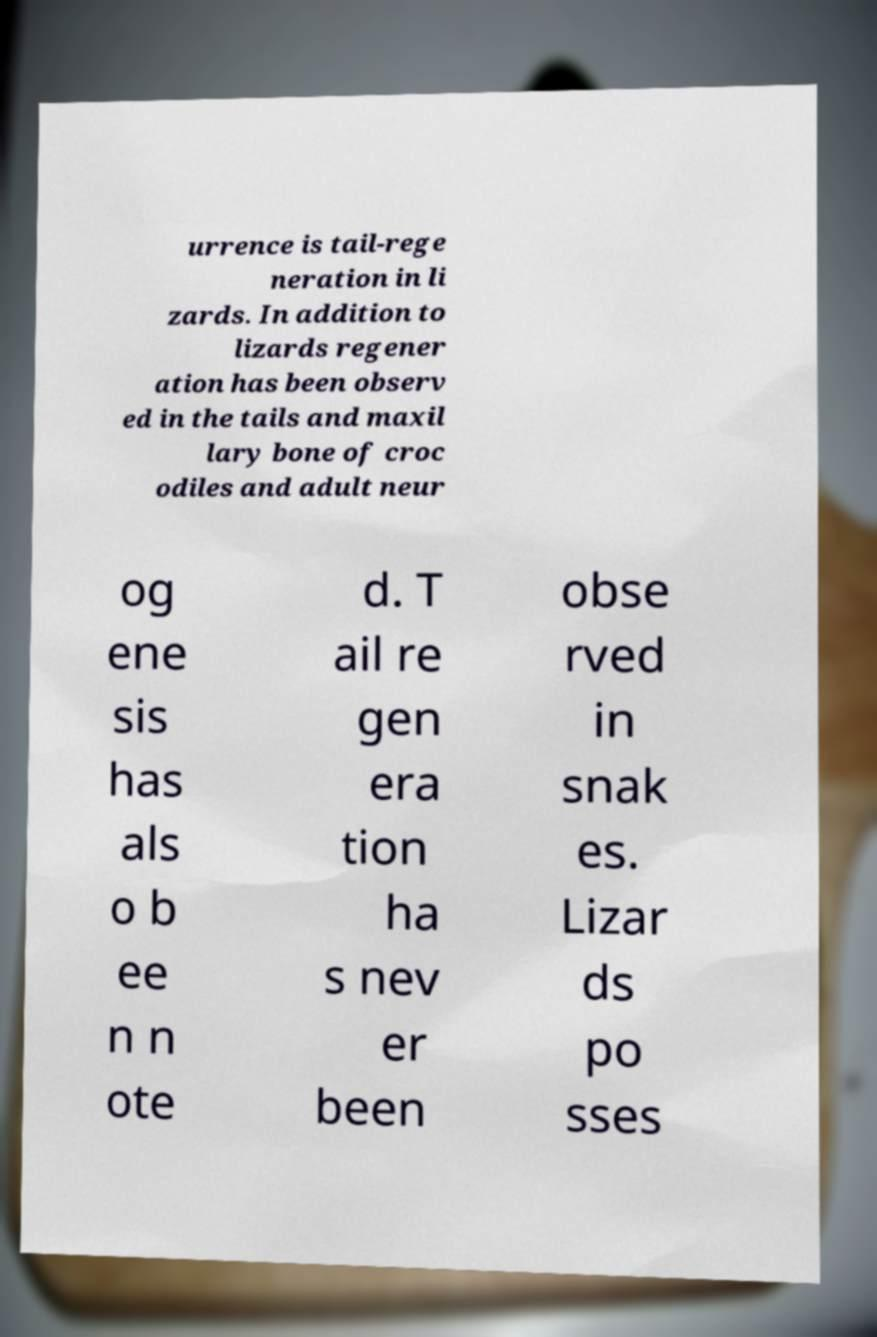Could you assist in decoding the text presented in this image and type it out clearly? urrence is tail-rege neration in li zards. In addition to lizards regener ation has been observ ed in the tails and maxil lary bone of croc odiles and adult neur og ene sis has als o b ee n n ote d. T ail re gen era tion ha s nev er been obse rved in snak es. Lizar ds po sses 